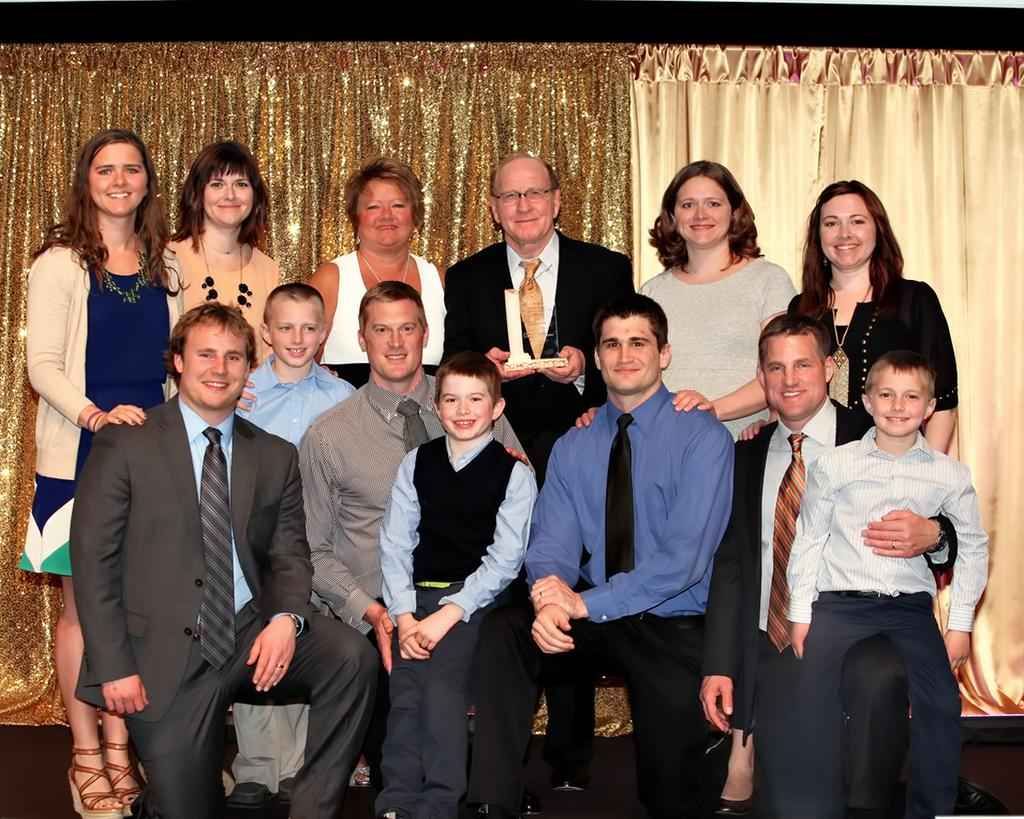How many people are in the image? There is a group of people in the image. What are the people in the image doing? Some people are standing, while others are in a squat position. What can be seen in the background of the image? There are curtains visible in the background of the image. What type of son is playing the guitar in the image? There is no son or guitar present in the image. What curve can be seen in the image? There is no curve visible in the image. 